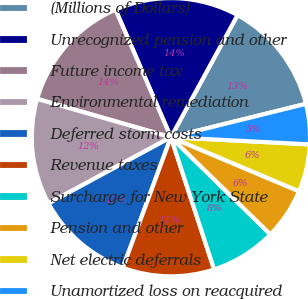<chart> <loc_0><loc_0><loc_500><loc_500><pie_chart><fcel>(Millions of Dollars)<fcel>Unrecognized pension and other<fcel>Future income tax<fcel>Environmental remediation<fcel>Deferred storm costs<fcel>Revenue taxes<fcel>Surcharge for New York State<fcel>Pension and other<fcel>Net electric deferrals<fcel>Unamortized loss on reacquired<nl><fcel>13.19%<fcel>14.47%<fcel>14.04%<fcel>12.34%<fcel>11.49%<fcel>10.64%<fcel>7.66%<fcel>5.96%<fcel>5.53%<fcel>4.68%<nl></chart> 